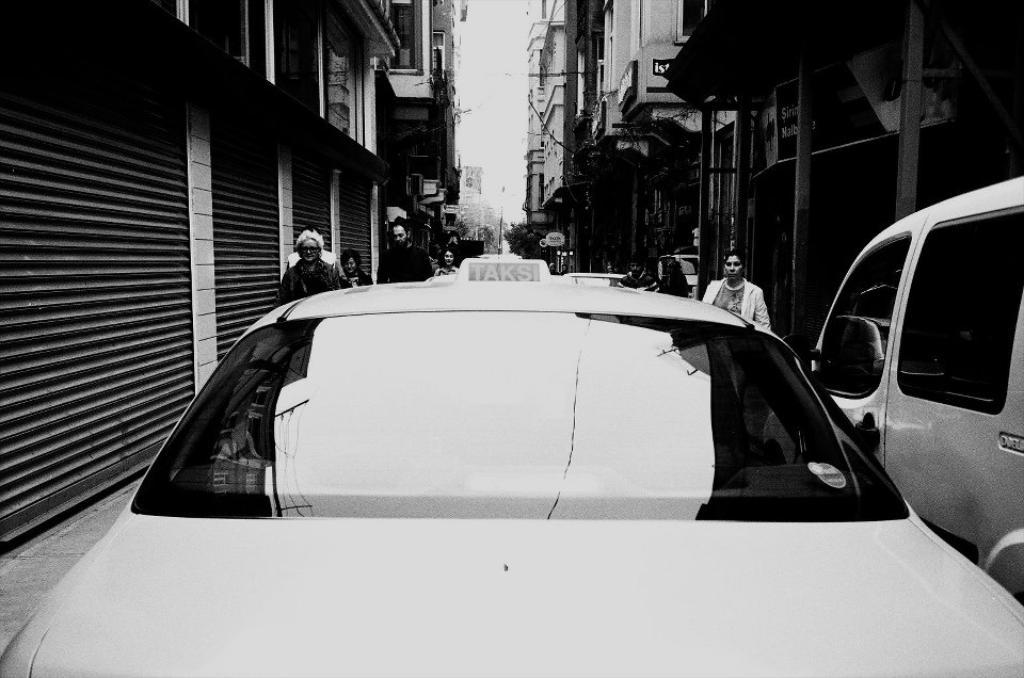What can be seen in the foreground of the image? There are two vehicles in the foreground of the image. Are there any people visible in the image? Yes, there are people visible behind the vehicles. What is visible in the background of the image? The sky is visible in the image. How many oranges are being used as decoration on the vehicles in the image? There are no oranges visible in the image, as it features two vehicles and people in the background. 